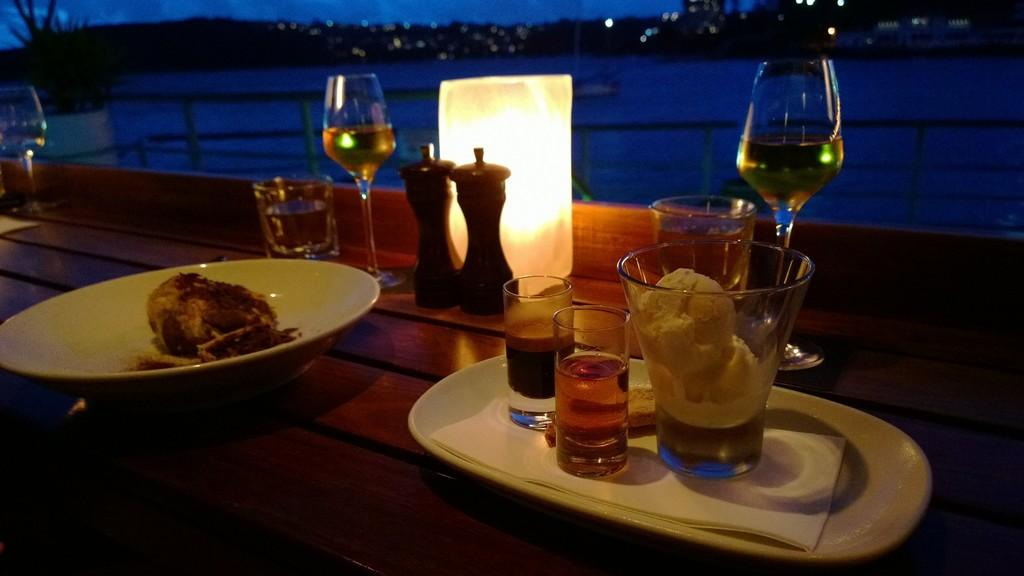What type of furniture is present in the image? There is a table in the image. What items can be seen on the table? There are glasses, bowls, plates, and desserts on the table. What additional item is on the table? There is a candle on the table. What can be seen in the background of the image? There is a lake and trees in the background of the image. What type of umbrella is being used to protect the desserts from the rain in the image? There is no umbrella present in the image, and the desserts are not being protected from the rain. 